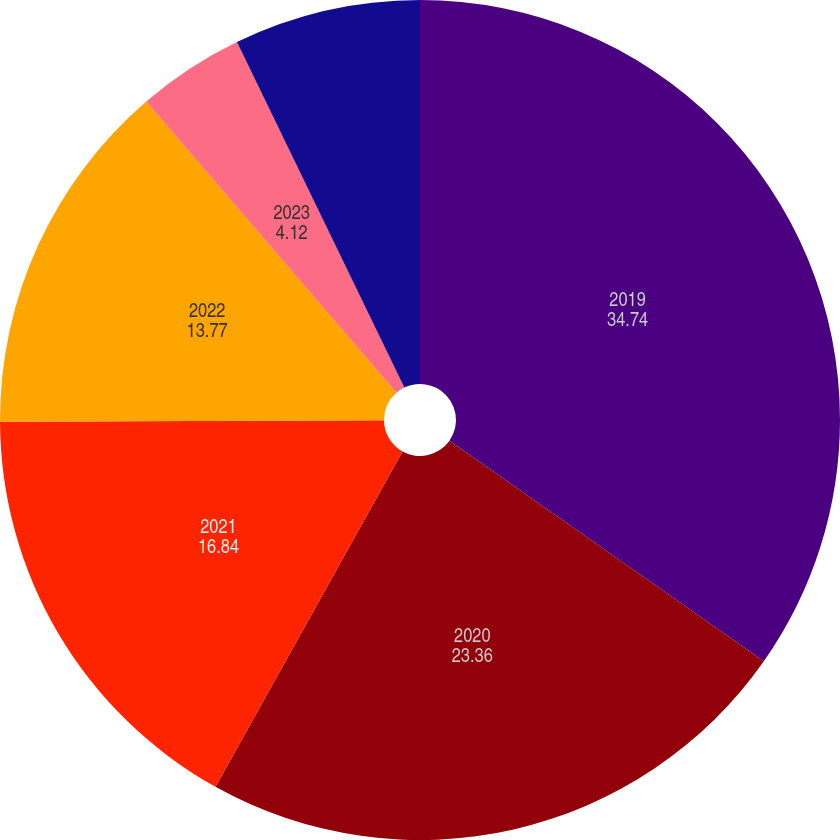Convert chart. <chart><loc_0><loc_0><loc_500><loc_500><pie_chart><fcel>2019<fcel>2020<fcel>2021<fcel>2022<fcel>2023<fcel>2024 and thereafter<nl><fcel>34.74%<fcel>23.36%<fcel>16.84%<fcel>13.77%<fcel>4.12%<fcel>7.18%<nl></chart> 